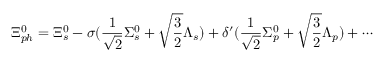<formula> <loc_0><loc_0><loc_500><loc_500>\Xi _ { p h } ^ { 0 } = \Xi _ { s } ^ { 0 } - \sigma ( \frac { 1 } { \sqrt { 2 } } \Sigma _ { s } ^ { 0 } + \sqrt { \frac { 3 } { 2 } } \Lambda _ { s } ) + \delta ^ { \prime } ( \frac { 1 } { \sqrt { 2 } } \Sigma _ { p } ^ { 0 } + \sqrt { \frac { 3 } { 2 } } \Lambda _ { p } ) + \cdots</formula> 